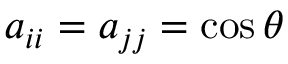Convert formula to latex. <formula><loc_0><loc_0><loc_500><loc_500>a _ { i i } = a _ { j j } = \cos \theta</formula> 